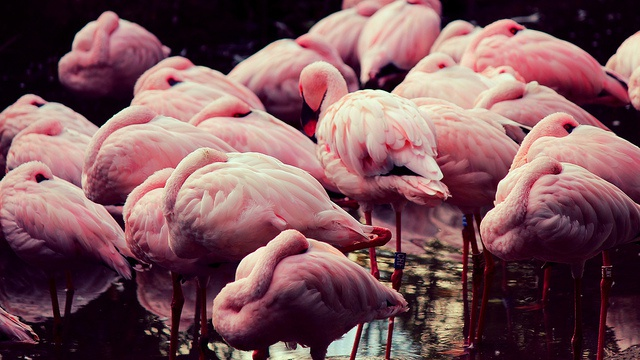Describe the objects in this image and their specific colors. I can see bird in black, lightpink, tan, and brown tones, bird in black, lightpink, brown, and maroon tones, bird in black, lightpink, brown, and purple tones, bird in black, lightpink, beige, brown, and tan tones, and bird in black, lightpink, brown, and purple tones in this image. 